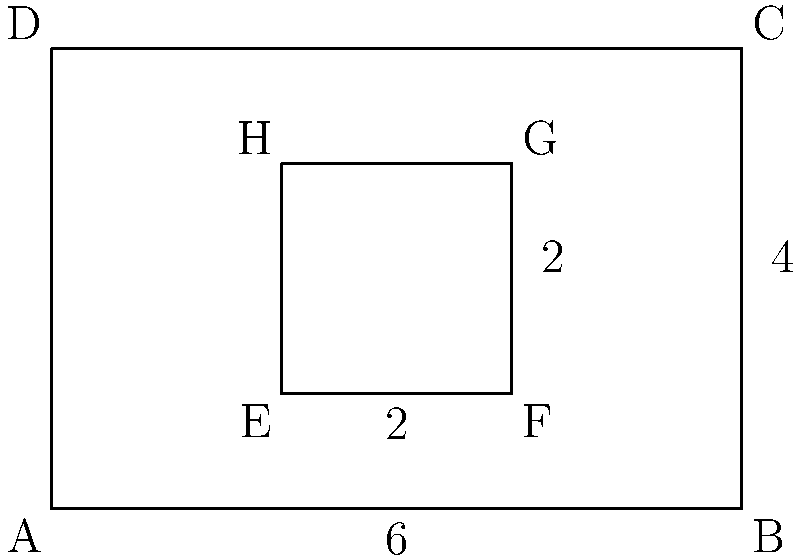As an experienced software developer, you're tasked with implementing an algorithm to calculate the perimeter of a complex shape formed by overlapping geometric figures. The shape consists of a rectangle ABCD with dimensions 6x4 units, and a smaller rectangle EFGH with dimensions 2x2 units inside it, as shown in the figure. What is the perimeter of the resulting shape? To calculate the perimeter of the complex shape, we need to follow these steps:

1. Identify the outer edges that contribute to the perimeter:
   - The entire bottom edge AB: 6 units
   - The entire right edge BC: 4 units
   - The entire top edge DC: 6 units
   - The entire left edge AD: 4 units

2. Identify the inner edges that contribute to the perimeter:
   - Left edge EH: 2 units
   - Top edge HG: 2 units
   - Right edge GF: 2 units
   - Bottom edge FE: 2 units

3. Calculate the total perimeter:
   $$\text{Perimeter} = AB + BC + CD + DA + EH + HG + GF + FE$$
   $$\text{Perimeter} = 6 + 4 + 6 + 4 + 2 + 2 + 2 + 2$$
   $$\text{Perimeter} = 20 + 8 = 28$$

Therefore, the perimeter of the resulting complex shape is 28 units.

This problem demonstrates the importance of carefully identifying all edges that contribute to the perimeter in a complex shape, which is crucial when implementing algorithms for geometric calculations in simulations.
Answer: 28 units 